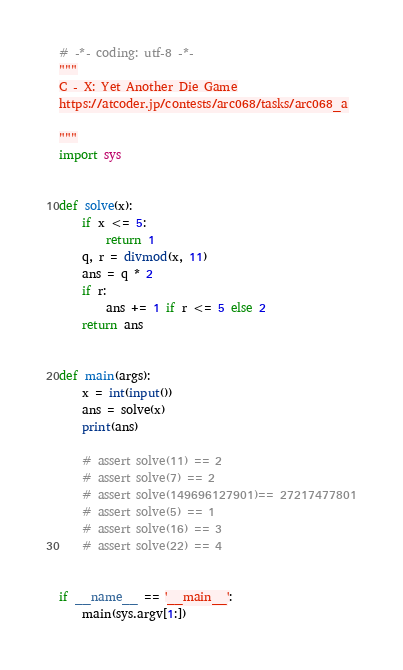<code> <loc_0><loc_0><loc_500><loc_500><_Python_># -*- coding: utf-8 -*-
"""
C - X: Yet Another Die Game
https://atcoder.jp/contests/arc068/tasks/arc068_a

"""
import sys


def solve(x):
    if x <= 5:
        return 1
    q, r = divmod(x, 11)
    ans = q * 2
    if r:
        ans += 1 if r <= 5 else 2
    return ans


def main(args):
    x = int(input())
    ans = solve(x)
    print(ans)

    # assert solve(11) == 2
    # assert solve(7) == 2
    # assert solve(149696127901)== 27217477801
    # assert solve(5) == 1
    # assert solve(16) == 3
    # assert solve(22) == 4


if __name__ == '__main__':
    main(sys.argv[1:])
</code> 